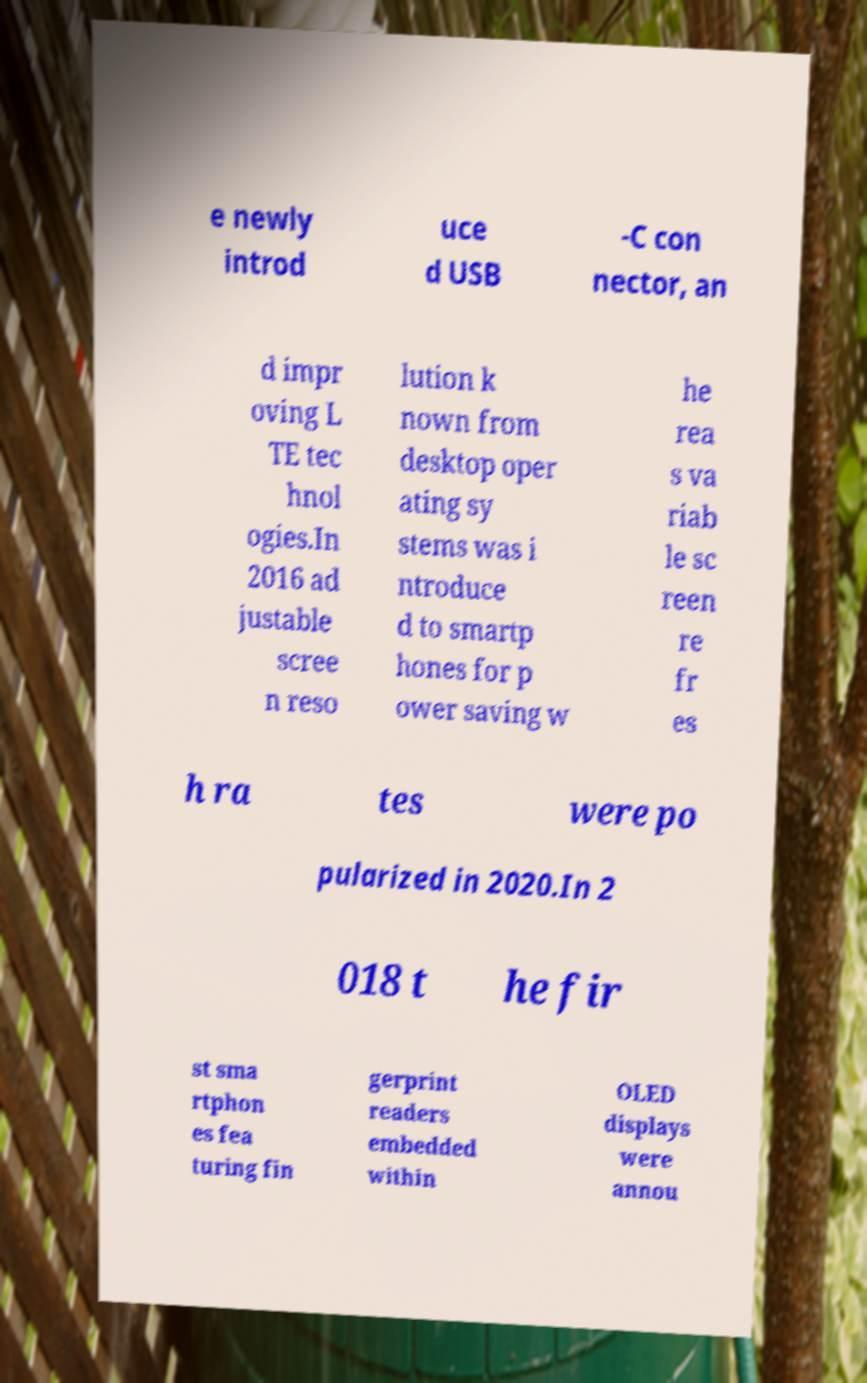There's text embedded in this image that I need extracted. Can you transcribe it verbatim? e newly introd uce d USB -C con nector, an d impr oving L TE tec hnol ogies.In 2016 ad justable scree n reso lution k nown from desktop oper ating sy stems was i ntroduce d to smartp hones for p ower saving w he rea s va riab le sc reen re fr es h ra tes were po pularized in 2020.In 2 018 t he fir st sma rtphon es fea turing fin gerprint readers embedded within OLED displays were annou 